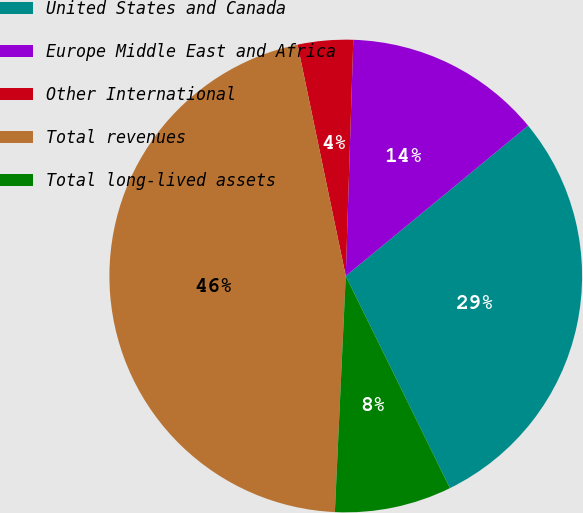Convert chart to OTSL. <chart><loc_0><loc_0><loc_500><loc_500><pie_chart><fcel>United States and Canada<fcel>Europe Middle East and Africa<fcel>Other International<fcel>Total revenues<fcel>Total long-lived assets<nl><fcel>28.71%<fcel>13.52%<fcel>3.78%<fcel>46.0%<fcel>8.0%<nl></chart> 